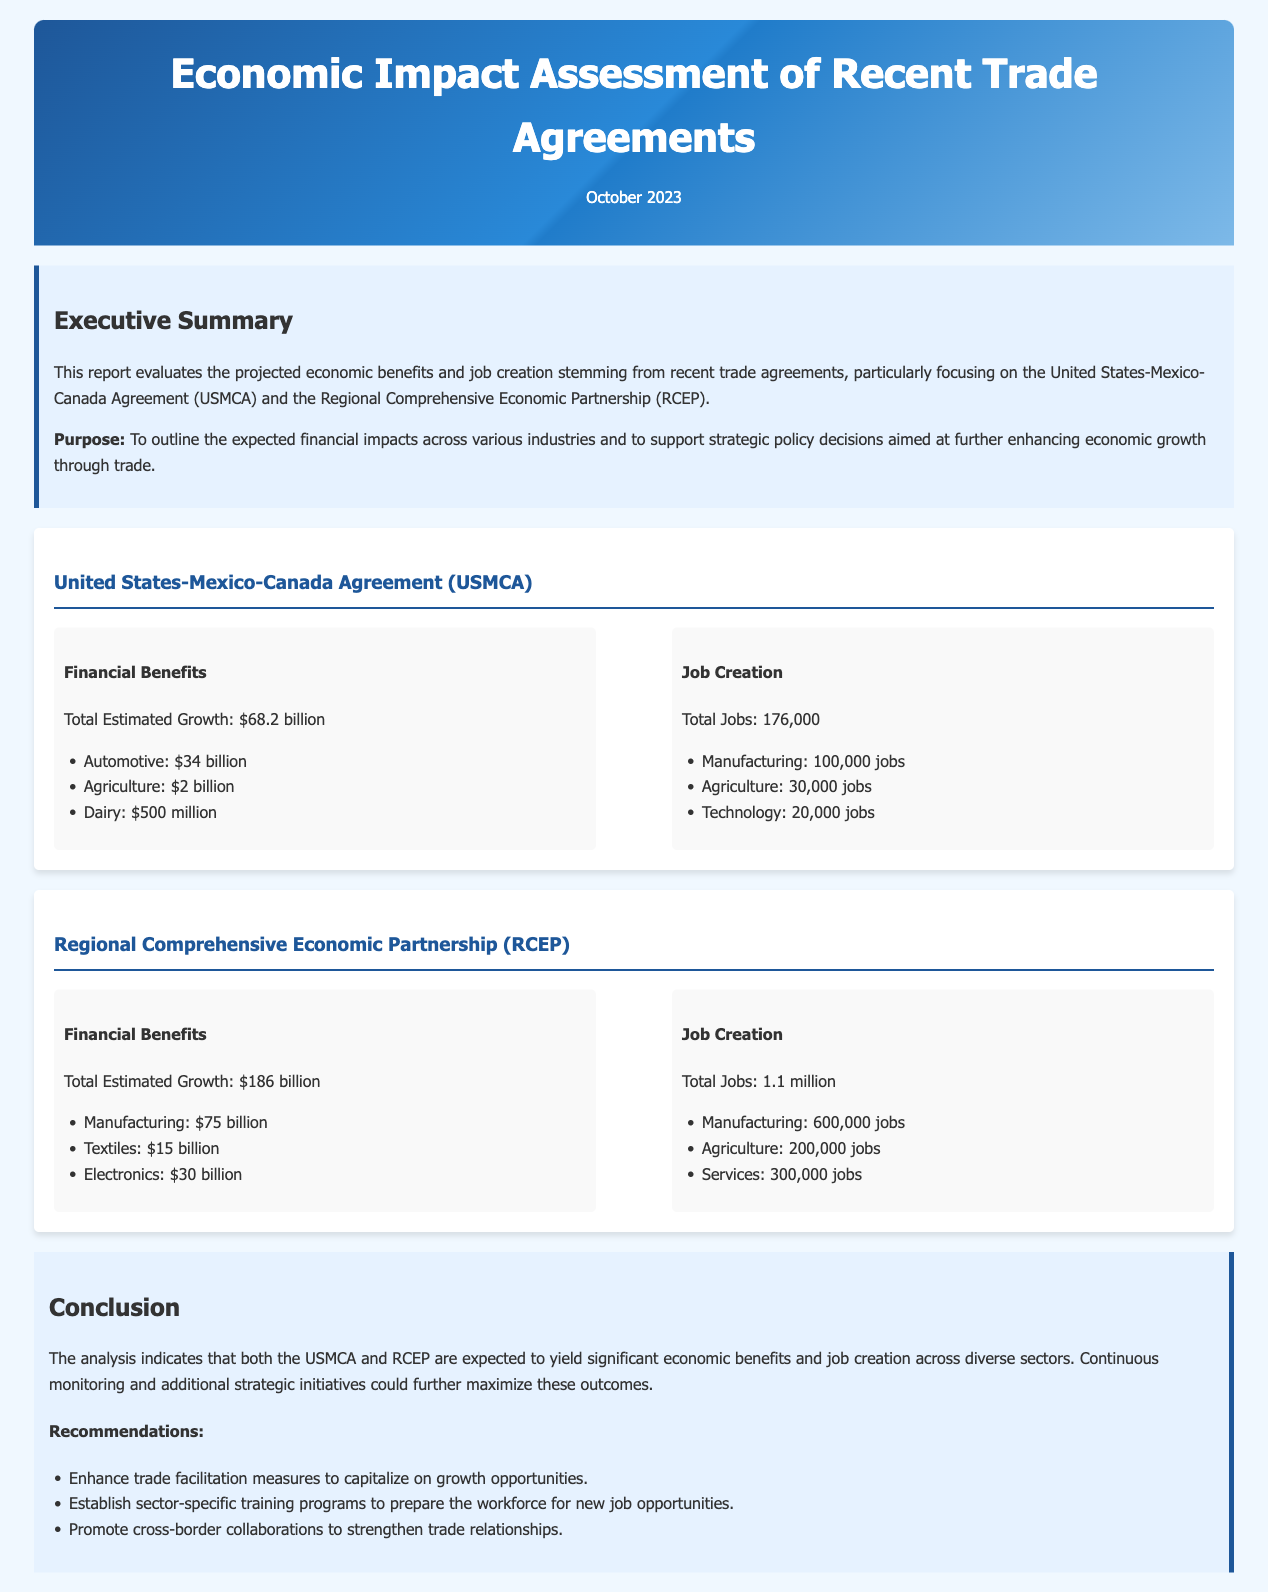What is the total estimated growth from the USMCA? The document states that the total estimated growth from the USMCA is $68.2 billion.
Answer: $68.2 billion How many jobs are projected to be created in agriculture under USMCA? The report indicates that the projected job creation in agriculture under USMCA is 30,000 jobs.
Answer: 30,000 jobs What is the total estimated growth from the RCEP? The document lists the total estimated growth from the RCEP as $186 billion.
Answer: $186 billion How many jobs in manufacturing are expected to be created under RCEP? The report specifies that RCEP is expected to create 600,000 jobs in manufacturing.
Answer: 600,000 jobs What is the largest financial benefit sector under RCEP? According to the document, the largest financial benefit sector under RCEP is manufacturing with $75 billion.
Answer: Manufacturing: $75 billion What type of recommendations are made in the conclusion? The conclusion section mentions recommendations such as enhancing trade facilitation measures and establishing sector-specific training programs.
Answer: Enhancing trade facilitation measures What is the total number of jobs estimated to be created under USMCA? The document states that the total number of jobs estimated to be created under USMCA is 176,000.
Answer: 176,000 Which trade agreement predicts the highest job creation? The document indicates that the RCEP predicts the highest job creation, with 1.1 million jobs.
Answer: RCEP What is the purpose of this financial report? The report outlines the expected financial impacts across various industries and supports strategic policy decisions for economic growth.
Answer: To outline expected financial impacts 